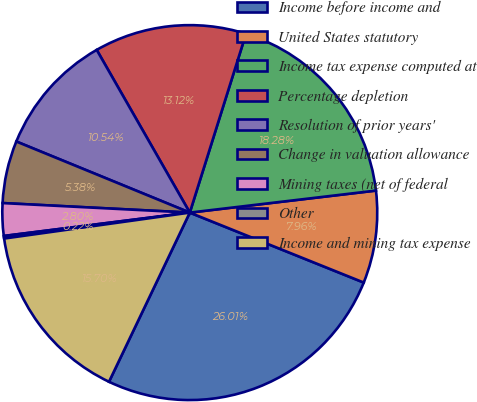<chart> <loc_0><loc_0><loc_500><loc_500><pie_chart><fcel>Income before income and<fcel>United States statutory<fcel>Income tax expense computed at<fcel>Percentage depletion<fcel>Resolution of prior years'<fcel>Change in valuation allowance<fcel>Mining taxes (net of federal<fcel>Other<fcel>Income and mining tax expense<nl><fcel>26.01%<fcel>7.96%<fcel>18.28%<fcel>13.12%<fcel>10.54%<fcel>5.38%<fcel>2.8%<fcel>0.22%<fcel>15.7%<nl></chart> 